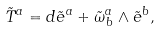Convert formula to latex. <formula><loc_0><loc_0><loc_500><loc_500>\tilde { T } ^ { a } = d \tilde { e } ^ { a } + \tilde { \omega } ^ { a } _ { \, b } \wedge \tilde { e } ^ { b } ,</formula> 